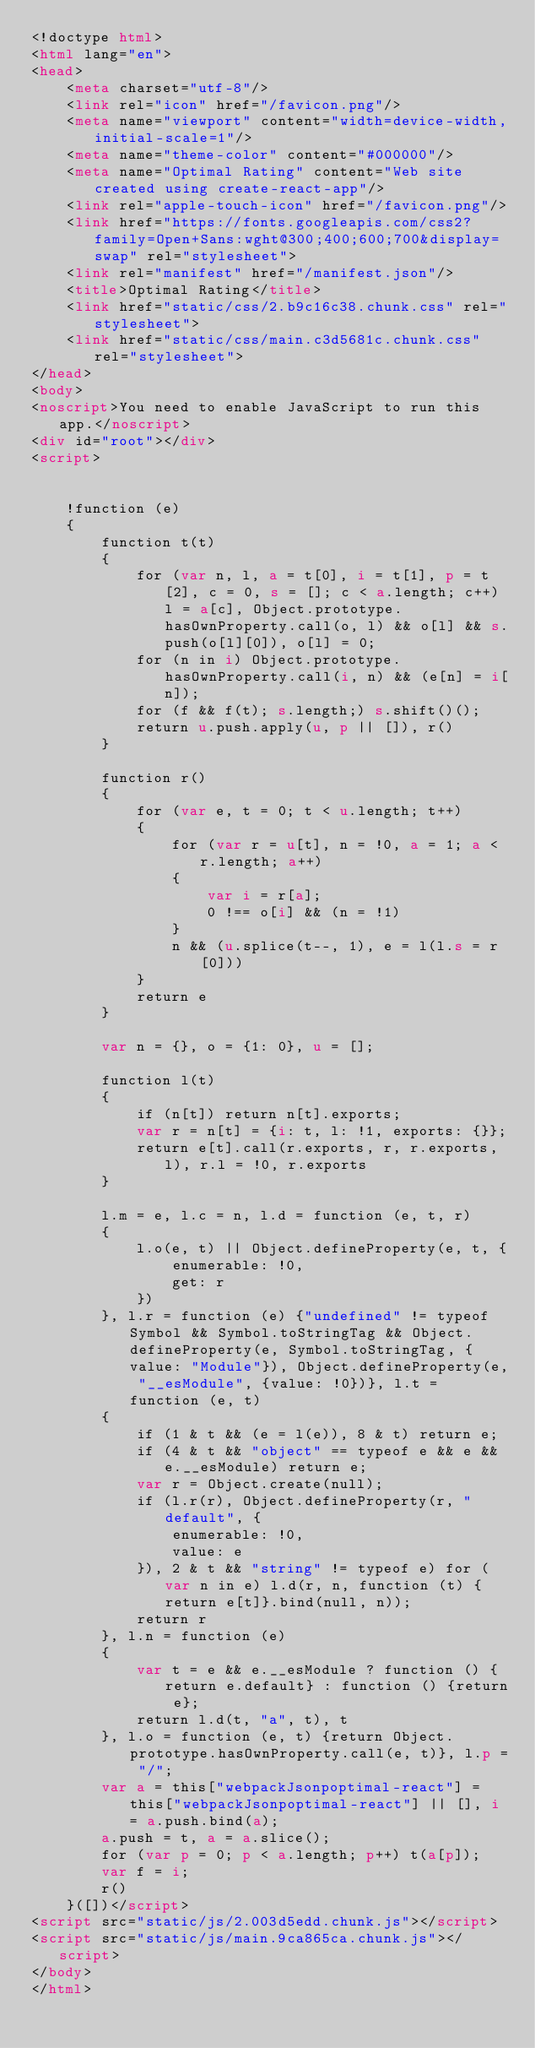<code> <loc_0><loc_0><loc_500><loc_500><_HTML_><!doctype html>
<html lang="en">
<head>
    <meta charset="utf-8"/>
    <link rel="icon" href="/favicon.png"/>
    <meta name="viewport" content="width=device-width,initial-scale=1"/>
    <meta name="theme-color" content="#000000"/>
    <meta name="Optimal Rating" content="Web site created using create-react-app"/>
    <link rel="apple-touch-icon" href="/favicon.png"/>
    <link href="https://fonts.googleapis.com/css2?family=Open+Sans:wght@300;400;600;700&display=swap" rel="stylesheet">
    <link rel="manifest" href="/manifest.json"/>
    <title>Optimal Rating</title>
    <link href="static/css/2.b9c16c38.chunk.css" rel="stylesheet">
    <link href="static/css/main.c3d5681c.chunk.css" rel="stylesheet">
</head>
<body>
<noscript>You need to enable JavaScript to run this app.</noscript>
<div id="root"></div>
<script>


    !function (e)
    {
        function t(t)
        {
            for (var n, l, a = t[0], i = t[1], p = t[2], c = 0, s = []; c < a.length; c++) l = a[c], Object.prototype.hasOwnProperty.call(o, l) && o[l] && s.push(o[l][0]), o[l] = 0;
            for (n in i) Object.prototype.hasOwnProperty.call(i, n) && (e[n] = i[n]);
            for (f && f(t); s.length;) s.shift()();
            return u.push.apply(u, p || []), r()
        }

        function r()
        {
            for (var e, t = 0; t < u.length; t++)
            {
                for (var r = u[t], n = !0, a = 1; a < r.length; a++)
                {
                    var i = r[a];
                    0 !== o[i] && (n = !1)
                }
                n && (u.splice(t--, 1), e = l(l.s = r[0]))
            }
            return e
        }

        var n = {}, o = {1: 0}, u = [];

        function l(t)
        {
            if (n[t]) return n[t].exports;
            var r = n[t] = {i: t, l: !1, exports: {}};
            return e[t].call(r.exports, r, r.exports, l), r.l = !0, r.exports
        }

        l.m = e, l.c = n, l.d = function (e, t, r)
        {
            l.o(e, t) || Object.defineProperty(e, t, {
                enumerable: !0,
                get: r
            })
        }, l.r = function (e) {"undefined" != typeof Symbol && Symbol.toStringTag && Object.defineProperty(e, Symbol.toStringTag, {value: "Module"}), Object.defineProperty(e, "__esModule", {value: !0})}, l.t = function (e, t)
        {
            if (1 & t && (e = l(e)), 8 & t) return e;
            if (4 & t && "object" == typeof e && e && e.__esModule) return e;
            var r = Object.create(null);
            if (l.r(r), Object.defineProperty(r, "default", {
                enumerable: !0,
                value: e
            }), 2 & t && "string" != typeof e) for (var n in e) l.d(r, n, function (t) {return e[t]}.bind(null, n));
            return r
        }, l.n = function (e)
        {
            var t = e && e.__esModule ? function () {return e.default} : function () {return e};
            return l.d(t, "a", t), t
        }, l.o = function (e, t) {return Object.prototype.hasOwnProperty.call(e, t)}, l.p = "/";
        var a = this["webpackJsonpoptimal-react"] = this["webpackJsonpoptimal-react"] || [], i = a.push.bind(a);
        a.push = t, a = a.slice();
        for (var p = 0; p < a.length; p++) t(a[p]);
        var f = i;
        r()
    }([])</script>
<script src="static/js/2.003d5edd.chunk.js"></script>
<script src="static/js/main.9ca865ca.chunk.js"></script>
</body>
</html>
</code> 